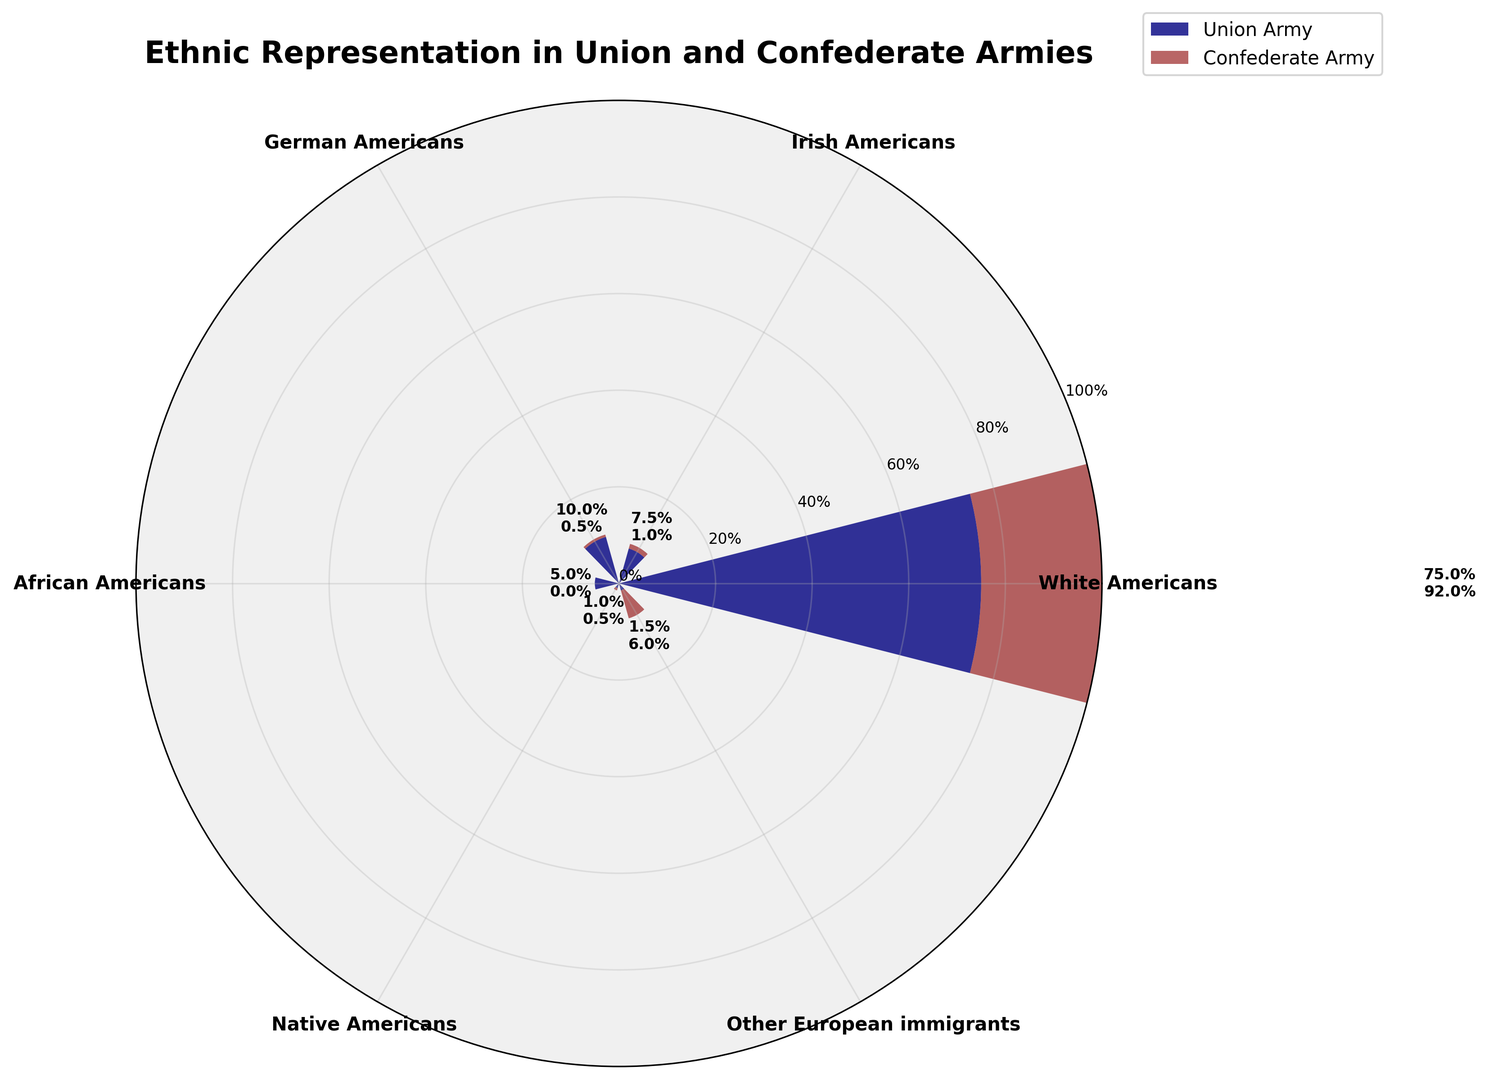What's the combined percentage of Irish Americans and German Americans in the Union Army? To find the combined percentage of Irish Americans and German Americans in the Union Army, sum their individual percentages: 7.5 + 10.
Answer: 17.5% Which army has a higher percentage of Other European immigrants, and by how much? Compare the percentages of Other European immigrants in both armies. Union Army has 1.5% and Confederate Army has 6%. Subtract the smaller percentage from the larger one: 6 - 1.5.
Answer: Confederate Army by 4.5% What is the difference in percentage between Irish Americans in the Union Army and the Confederate Army? Subtract the percentage of Irish Americans in the Confederate Army from that in the Union Army: 7.5 - 1.
Answer: 6.5% Which ethnicity contributes the largest percentage to the Confederate Army, and what is that percentage? Identify the ethnicity with the highest percentage in the Confederate Army, which is White Americans with 92%.
Answer: White Americans, 92% What proportion of African Americans were in the Union Army compared to the Confederate Army? Compare the percentages of African Americans in both armies. The Union Army has 5% and the Confederate Army has 0%.
Answer: Union Army has all of the African Americans since the Confederate Army has 0% What's the total percentage of Native Americans and Other European immigrants in the Confederate Army? Add the percentages of Native Americans and Other European immigrants in the Confederate Army: 0.5 + 6.
Answer: 6.5% Which group has the largest difference in representation between the Union and Confederate armies? Calculate the differences for each group: White Americans (92 - 75 = 17), Irish Americans (7.5 - 1 = 6.5), German Americans (10 - 0.5 = 9.5), African Americans (5 - 0 = 5), Native Americans (1 - 0.5 = 0.5), Other European immigrants (1.5 - 6 = -4.5). The largest difference is for White Americans.
Answer: White Americans, 17% Among the Irish Americans in both armies, which percentage is greater and by how much? Compare the percentages: Union Army has 7.5%, and Confederate Army has 1%. Subtract the smaller percentage from the larger one: 7.5 - 1.
Answer: Union Army by 6.5% Which group has the smallest representation in the Union Army, and what is the percentage? Identify the ethnicity with the smallest percentage in the Union Army, which is Native Americans with 1%.
Answer: Native Americans, 1% What is the total percentage of all ethnicities in the Union Army? Sum the percentages of all ethnicities in the Union Army: 75 + 7.5 + 10 + 5 + 1 + 1.5.
Answer: 100% 